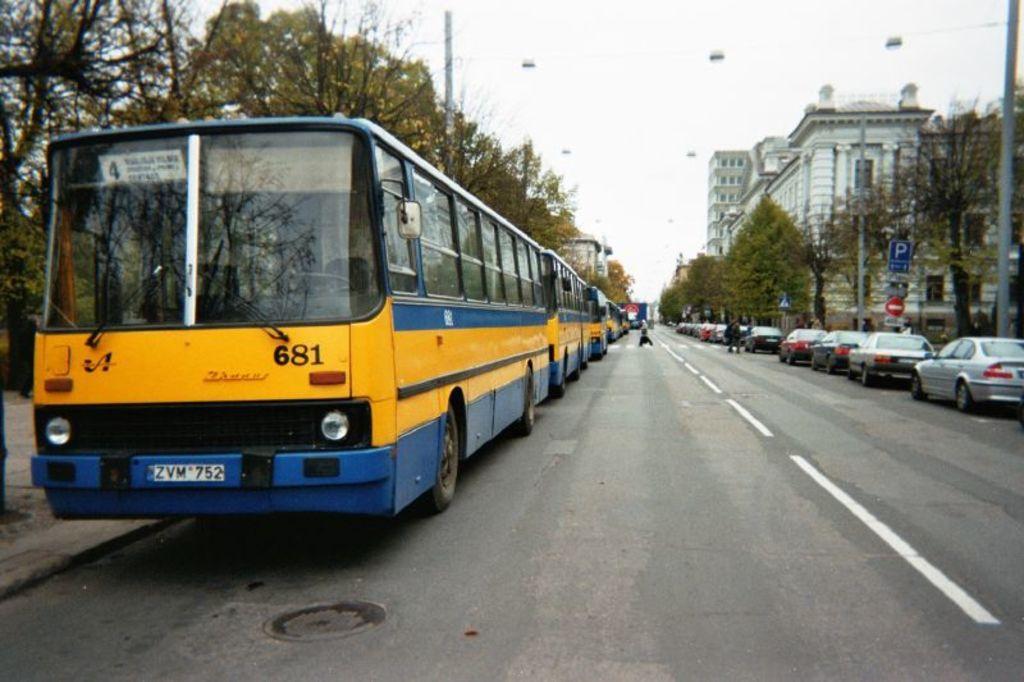Please provide a concise description of this image. In this picture we can see few vehicles and few persons on the road, beside to the road we can find few poles, sign boards, trees and buildings. 